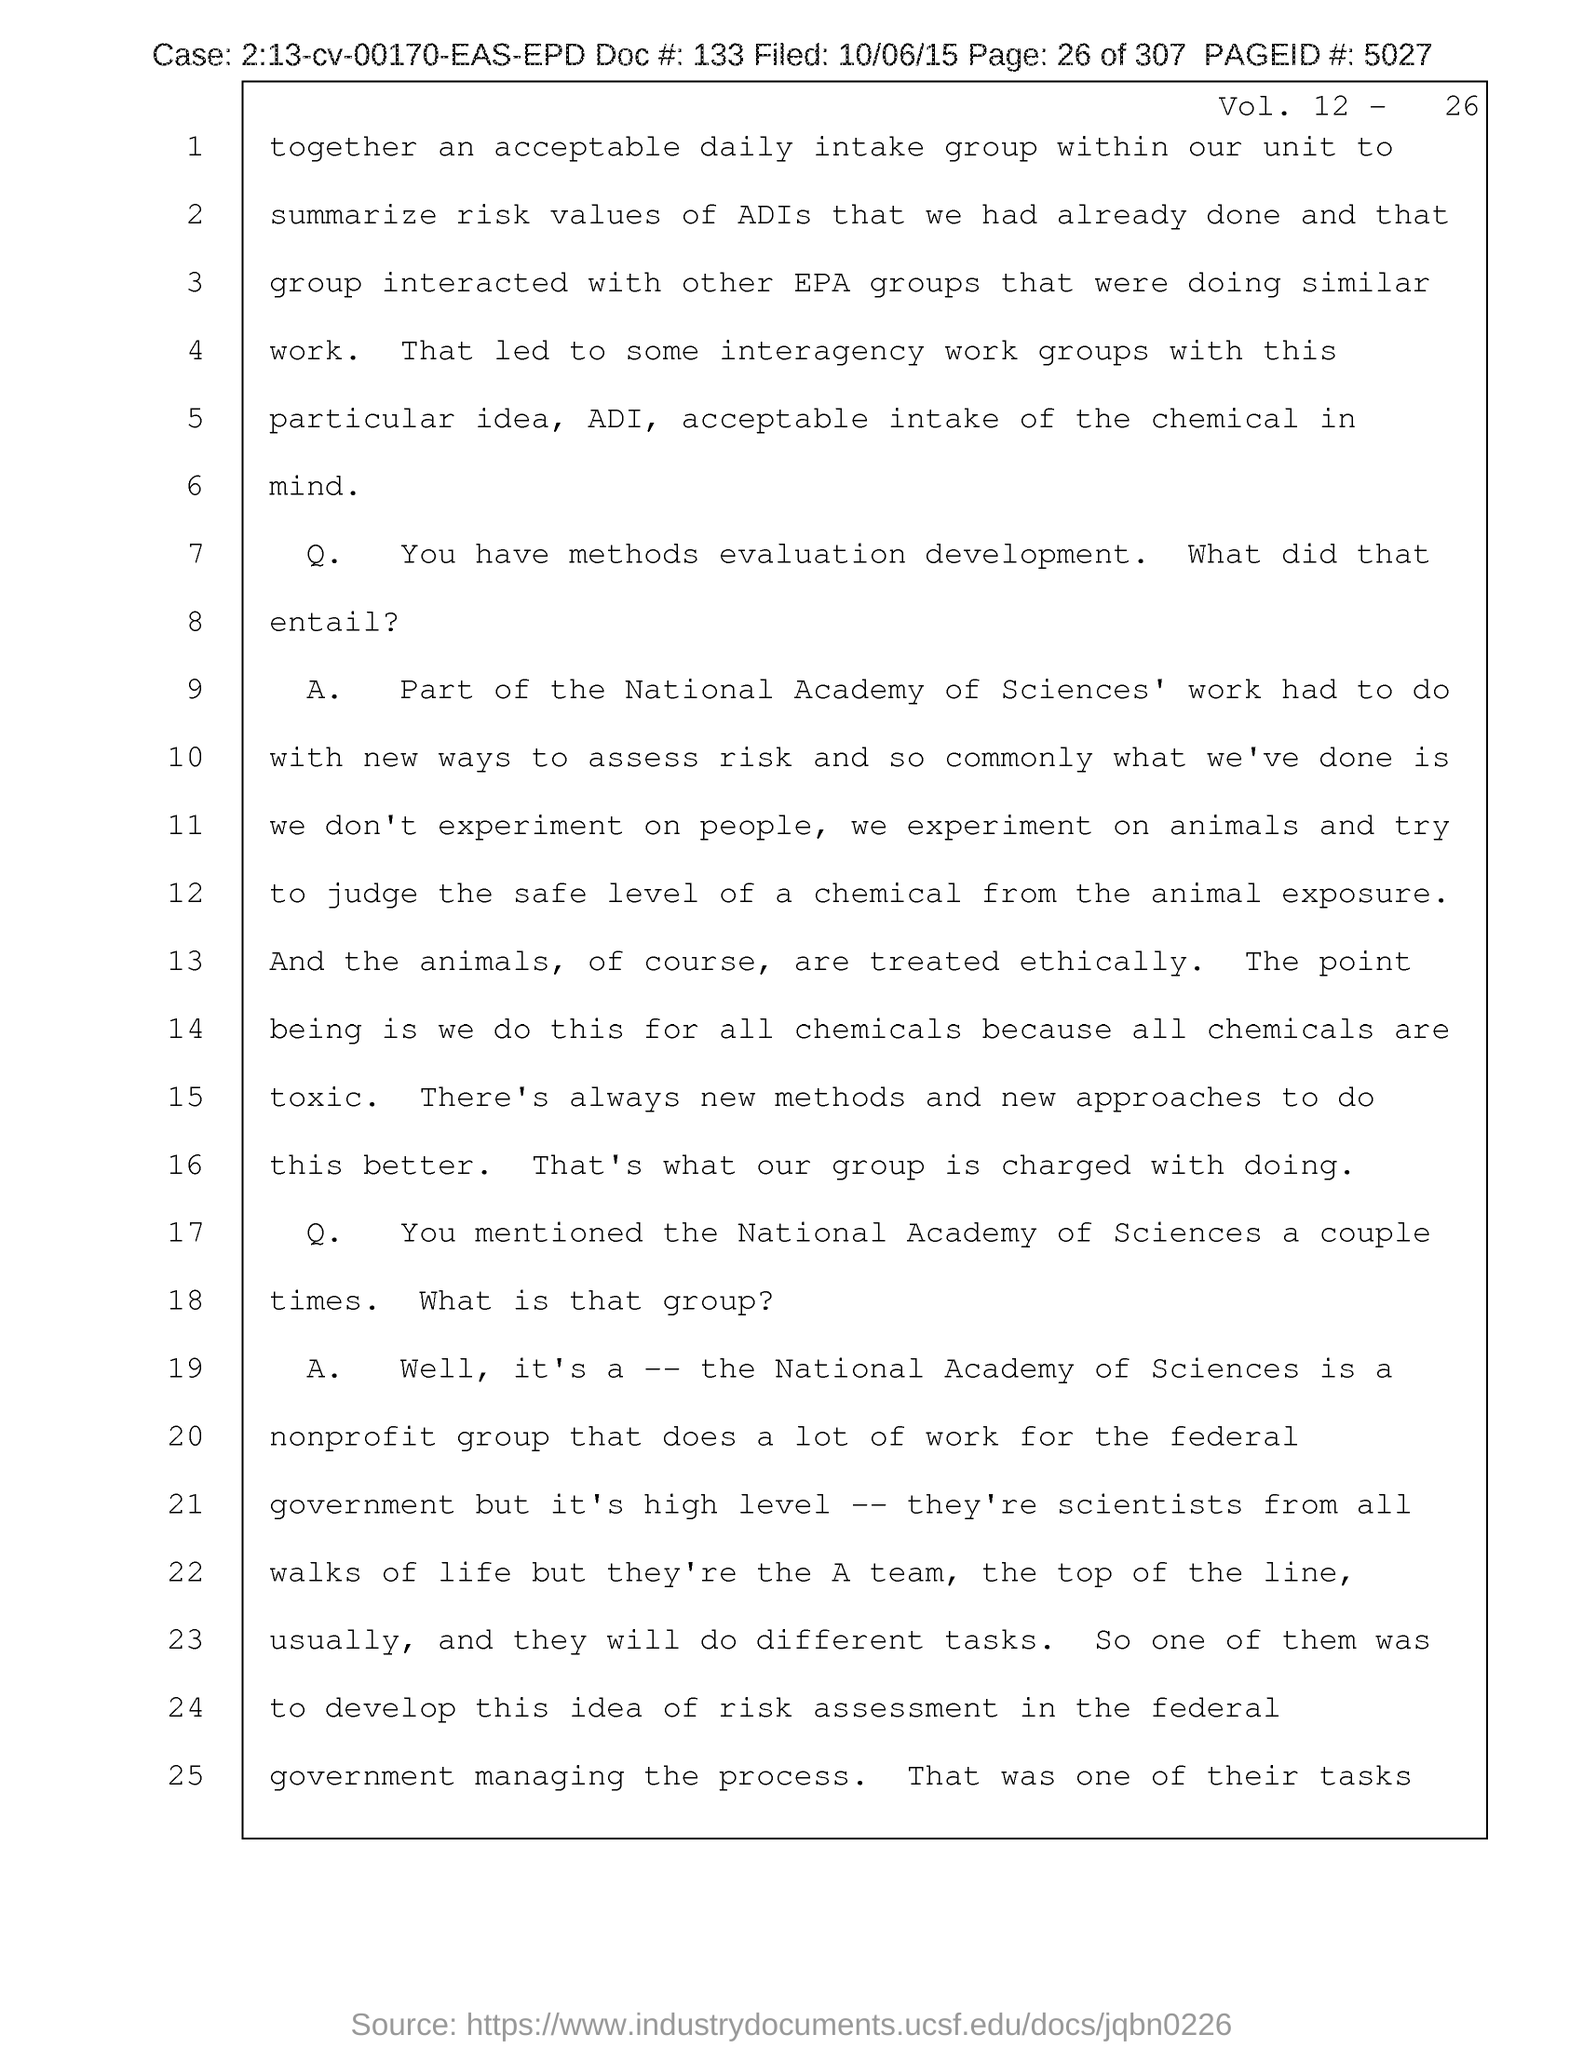What is the Vol. no. given in the document?
Offer a very short reply. Vol. 12 - 26. What is the case no mentioned in the document?
Provide a short and direct response. 2.13-cv-00170-EAS-EPD. What is the doc# given in the document?
Offer a terse response. 133. What is the page no mentioned in this document?
Provide a short and direct response. 26 of 307. What is the Page ID # given in the document?
Provide a succinct answer. 5027. What is the filed date of the document?
Your answer should be compact. 10/06/15. 